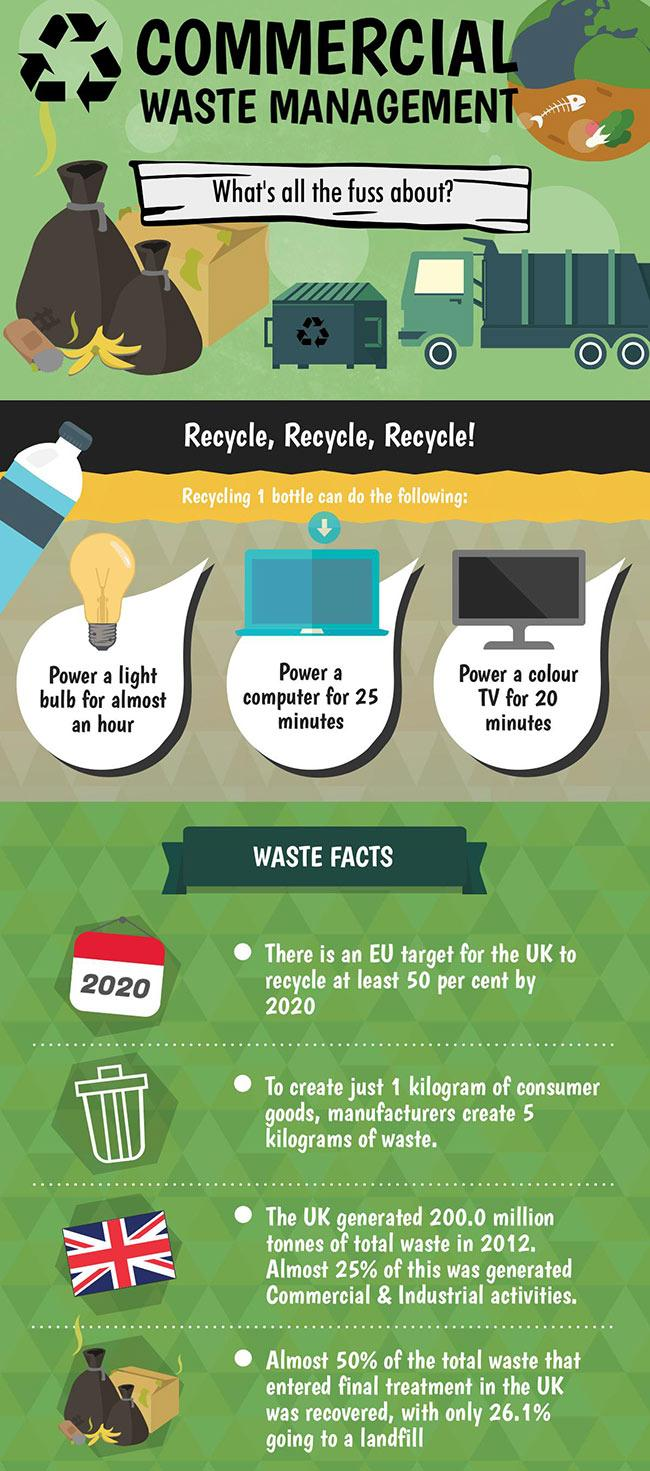Mention a couple of crucial points in this snapshot. A color television can be powered for 20 minutes using just one recycled plastic bottle. Three electrical appliances, a light bulb, computer, and color TV, can be powered from a single recycled bottle. It is necessary to recycle a certain number of plastic bottles in order to power one light bulb for an hour. Commercial and industrial activities generated approximately 50 million tonnes of total waste in 2020. The image next to the third bullet point is a flag. 